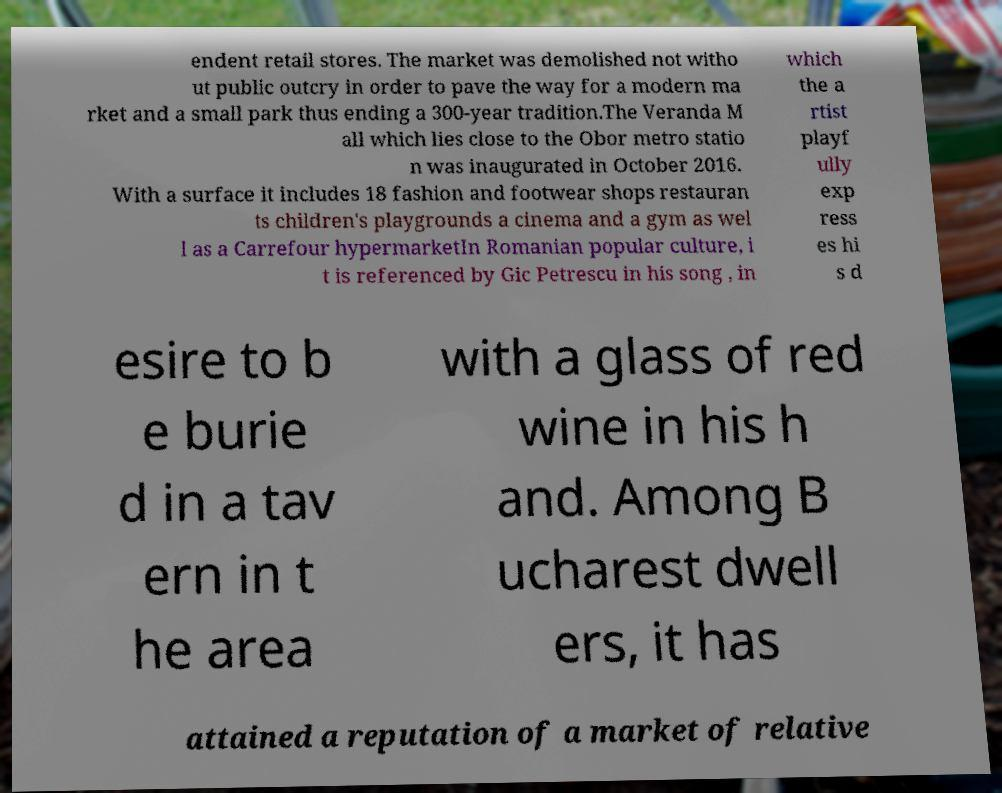Could you extract and type out the text from this image? endent retail stores. The market was demolished not witho ut public outcry in order to pave the way for a modern ma rket and a small park thus ending a 300-year tradition.The Veranda M all which lies close to the Obor metro statio n was inaugurated in October 2016. With a surface it includes 18 fashion and footwear shops restauran ts children's playgrounds a cinema and a gym as wel l as a Carrefour hypermarketIn Romanian popular culture, i t is referenced by Gic Petrescu in his song , in which the a rtist playf ully exp ress es hi s d esire to b e burie d in a tav ern in t he area with a glass of red wine in his h and. Among B ucharest dwell ers, it has attained a reputation of a market of relative 